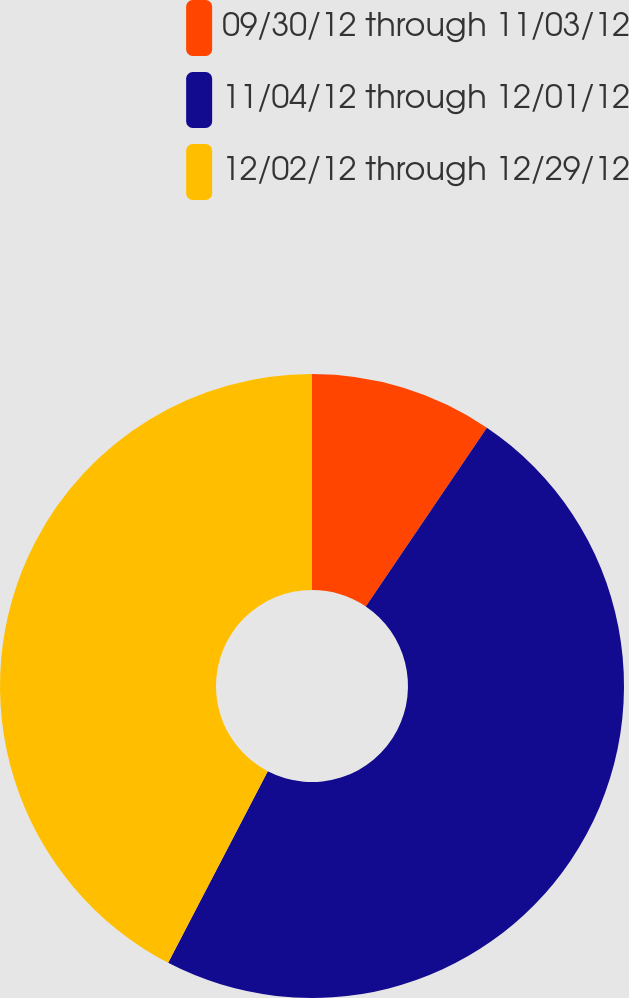<chart> <loc_0><loc_0><loc_500><loc_500><pie_chart><fcel>09/30/12 through 11/03/12<fcel>11/04/12 through 12/01/12<fcel>12/02/12 through 12/29/12<nl><fcel>9.47%<fcel>48.15%<fcel>42.37%<nl></chart> 